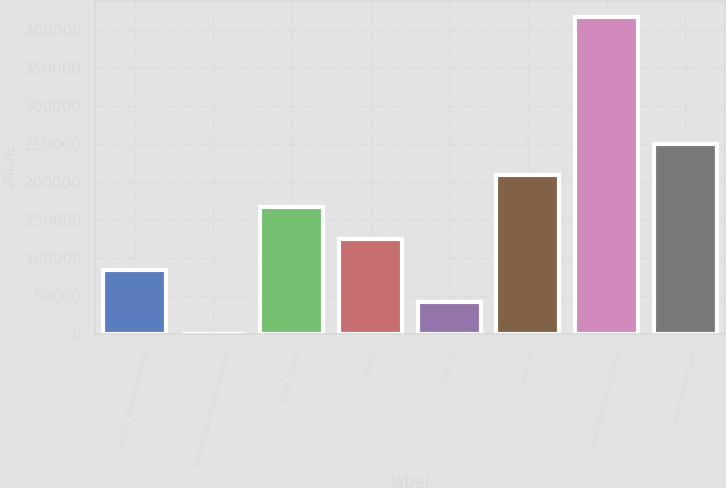<chart> <loc_0><loc_0><loc_500><loc_500><bar_chart><fcel>where otherwise noted)<fcel>Market risk-related revenue -<fcel>Fixed Income<fcel>Equity<fcel>Other (b)<fcel>Total AUC<fcel>Client deposits and other<fcel>Trade finance loans<nl><fcel>83481<fcel>9<fcel>166953<fcel>125217<fcel>41745<fcel>208689<fcel>417369<fcel>250425<nl></chart> 